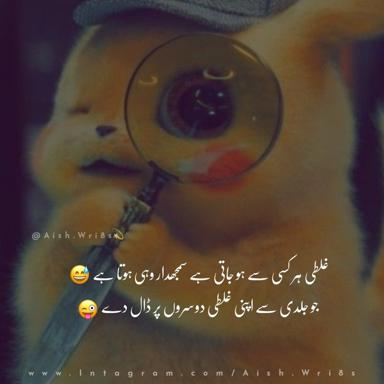What does the magnifying glass in the Pikachu hat suggest about the theme or use of this hat? The inclusion of a magnifying glass on the Pikachu hat suggests a theme of exploration and discovery. This playful addition transforms the hat from a simple headwear item into a tool for adventure, possibly encouraging the wearer to engage in detective work or explore their surroundings more closely, much like a character in a Pokemon game. 